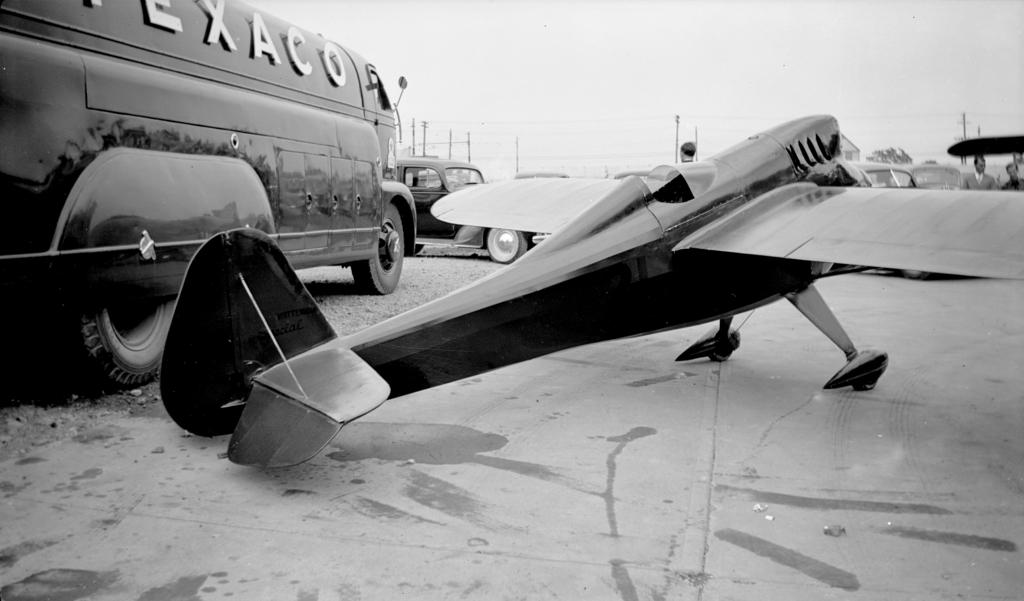What is the color scheme of the image? The image is in black and white. What type of vehicle is present in the image? There is a chopper and a van in the image. Are there any other vehicles in the image? Yes, there are cars in the image. What can be seen in the background of the image? The background of the image includes poles and wires. Are there any people visible in the image? Yes, there are persons behind the chopper. What type of sock is hanging from the pole in the image? There is no sock present in the image; the background elements include poles and wires, but no sock is visible. Can you tell me how many corn plants are growing near the van in the image? There is no corn plant present in the image; the background elements include poles and wires, but no corn plants are visible. 